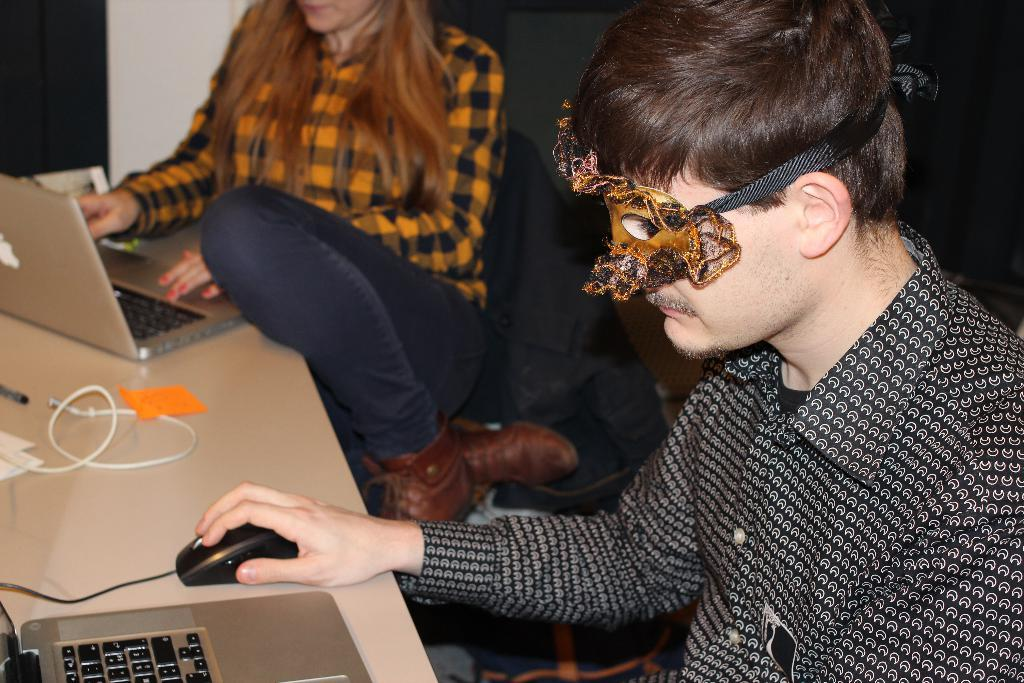How many people are in the image? There are two people in the image. What are the people doing in the image? The people are sitting on chairs. What is on the table in front of the chairs? There are laptops and wires on the table. What can be seen in the background of the image? There is a wall in the background of the image. What type of scale is used by the people in the image? There is no scale present in the image; the people are using laptops on a table. Can you tell me how many robins are perched on the wall in the image? There are no robins present in the image; the background features a wall with no visible birds. 